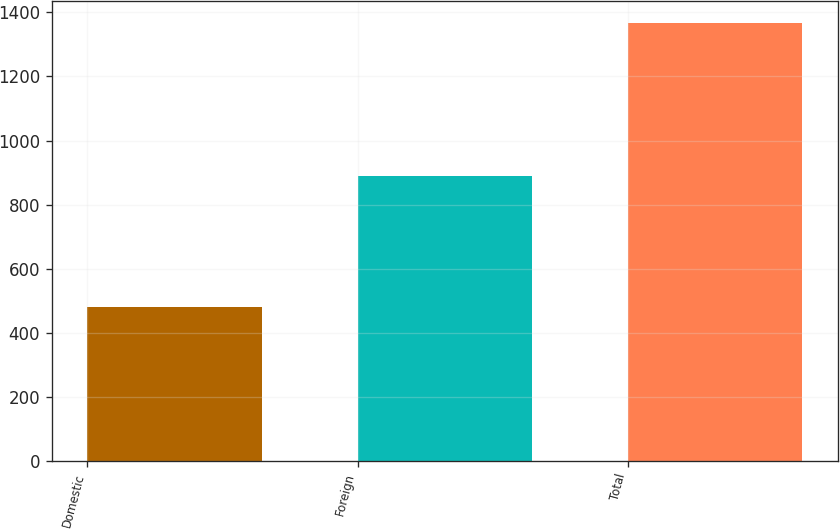Convert chart to OTSL. <chart><loc_0><loc_0><loc_500><loc_500><bar_chart><fcel>Domestic<fcel>Foreign<fcel>Total<nl><fcel>480<fcel>888<fcel>1368<nl></chart> 